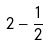Convert formula to latex. <formula><loc_0><loc_0><loc_500><loc_500>2 - \frac { 1 } { 2 }</formula> 